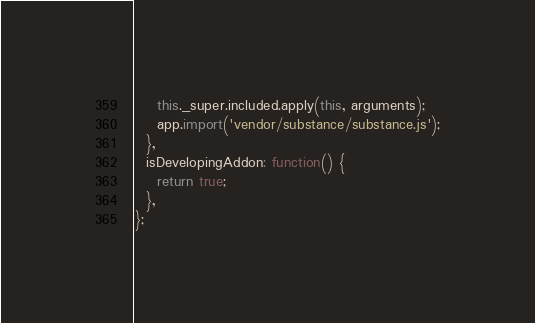Convert code to text. <code><loc_0><loc_0><loc_500><loc_500><_JavaScript_>    this._super.included.apply(this, arguments);
    app.import('vendor/substance/substance.js');
  },
  isDevelopingAddon: function() {
    return true;
  },
};
</code> 